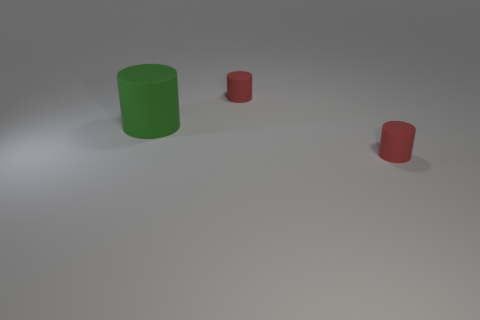Add 2 large green cylinders. How many objects exist? 5 Subtract 0 purple cubes. How many objects are left? 3 Subtract all big purple cylinders. Subtract all small objects. How many objects are left? 1 Add 2 green matte objects. How many green matte objects are left? 3 Add 1 gray spheres. How many gray spheres exist? 1 